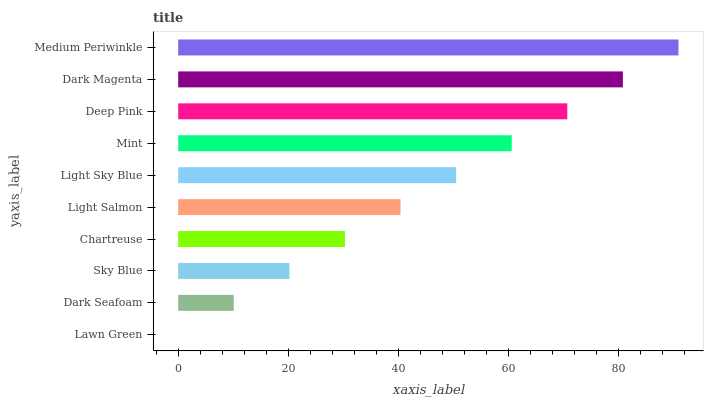Is Lawn Green the minimum?
Answer yes or no. Yes. Is Medium Periwinkle the maximum?
Answer yes or no. Yes. Is Dark Seafoam the minimum?
Answer yes or no. No. Is Dark Seafoam the maximum?
Answer yes or no. No. Is Dark Seafoam greater than Lawn Green?
Answer yes or no. Yes. Is Lawn Green less than Dark Seafoam?
Answer yes or no. Yes. Is Lawn Green greater than Dark Seafoam?
Answer yes or no. No. Is Dark Seafoam less than Lawn Green?
Answer yes or no. No. Is Light Sky Blue the high median?
Answer yes or no. Yes. Is Light Salmon the low median?
Answer yes or no. Yes. Is Dark Magenta the high median?
Answer yes or no. No. Is Mint the low median?
Answer yes or no. No. 